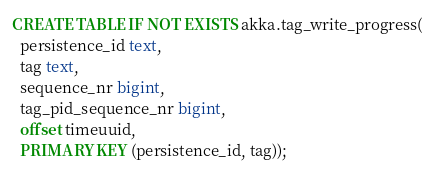<code> <loc_0><loc_0><loc_500><loc_500><_SQL_>
CREATE TABLE IF NOT EXISTS akka.tag_write_progress(
  persistence_id text,
  tag text,
  sequence_nr bigint,
  tag_pid_sequence_nr bigint,
  offset timeuuid,
  PRIMARY KEY (persistence_id, tag));</code> 